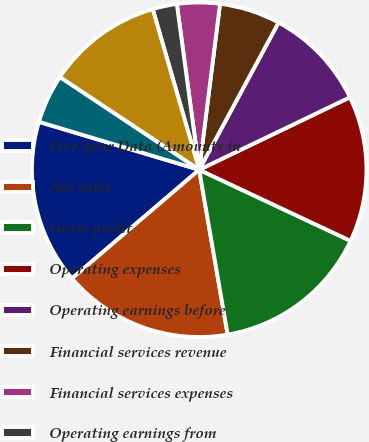<chart> <loc_0><loc_0><loc_500><loc_500><pie_chart><fcel>Five-year Data (Amounts in<fcel>Net sales<fcel>Gross profit<fcel>Operating expenses<fcel>Operating earnings before<fcel>Financial services revenue<fcel>Financial services expenses<fcel>Operating earnings from<fcel>Operating earnings<fcel>Interest expense<nl><fcel>15.88%<fcel>16.47%<fcel>15.29%<fcel>14.12%<fcel>10.0%<fcel>5.88%<fcel>4.12%<fcel>2.35%<fcel>11.18%<fcel>4.71%<nl></chart> 